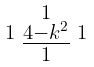Convert formula to latex. <formula><loc_0><loc_0><loc_500><loc_500>\begin{smallmatrix} & 1 & \\ 1 & \underline { 4 - k ^ { 2 } } & 1 \\ & 1 & \end{smallmatrix}</formula> 